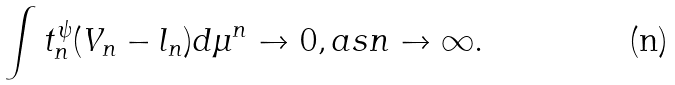<formula> <loc_0><loc_0><loc_500><loc_500>\int t _ { n } ^ { \psi } ( V _ { n } - l _ { n } ) d \mu ^ { n } \to 0 , a s n \to \infty .</formula> 